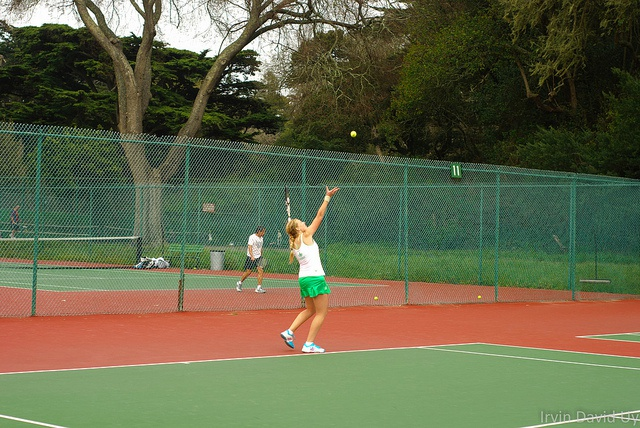Describe the objects in this image and their specific colors. I can see people in lightgray, white, tan, and salmon tones, people in lightgray, gray, darkgray, and tan tones, bench in lightgray, green, and darkgreen tones, people in lightgray, gray, teal, black, and maroon tones, and tennis racket in lightgray, gray, olive, and darkgray tones in this image. 